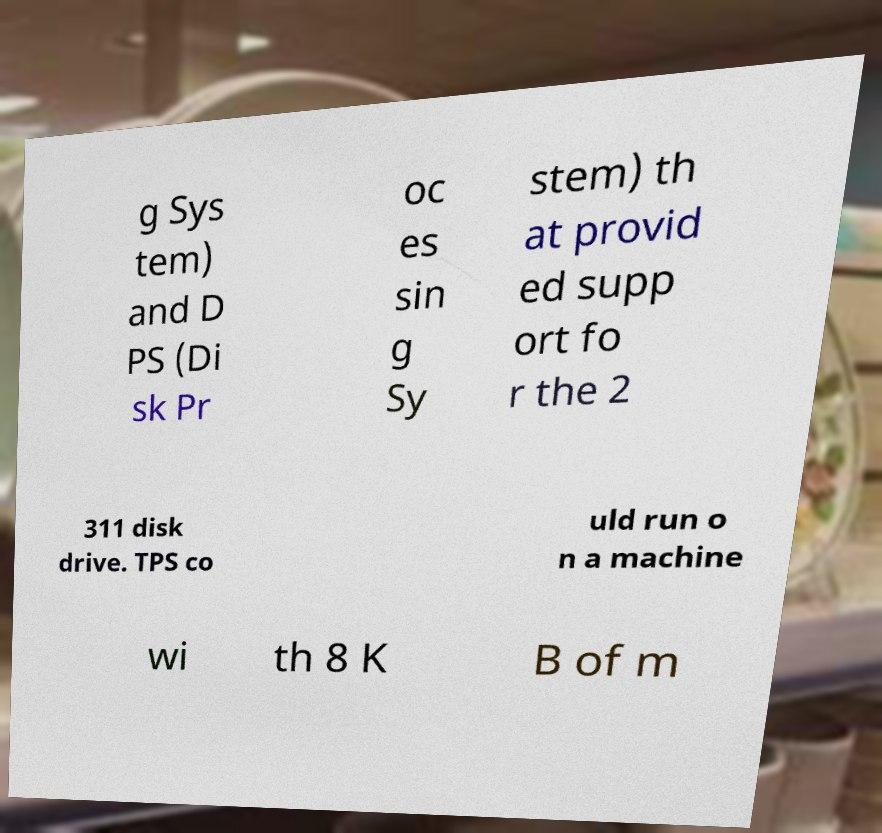Can you accurately transcribe the text from the provided image for me? g Sys tem) and D PS (Di sk Pr oc es sin g Sy stem) th at provid ed supp ort fo r the 2 311 disk drive. TPS co uld run o n a machine wi th 8 K B of m 